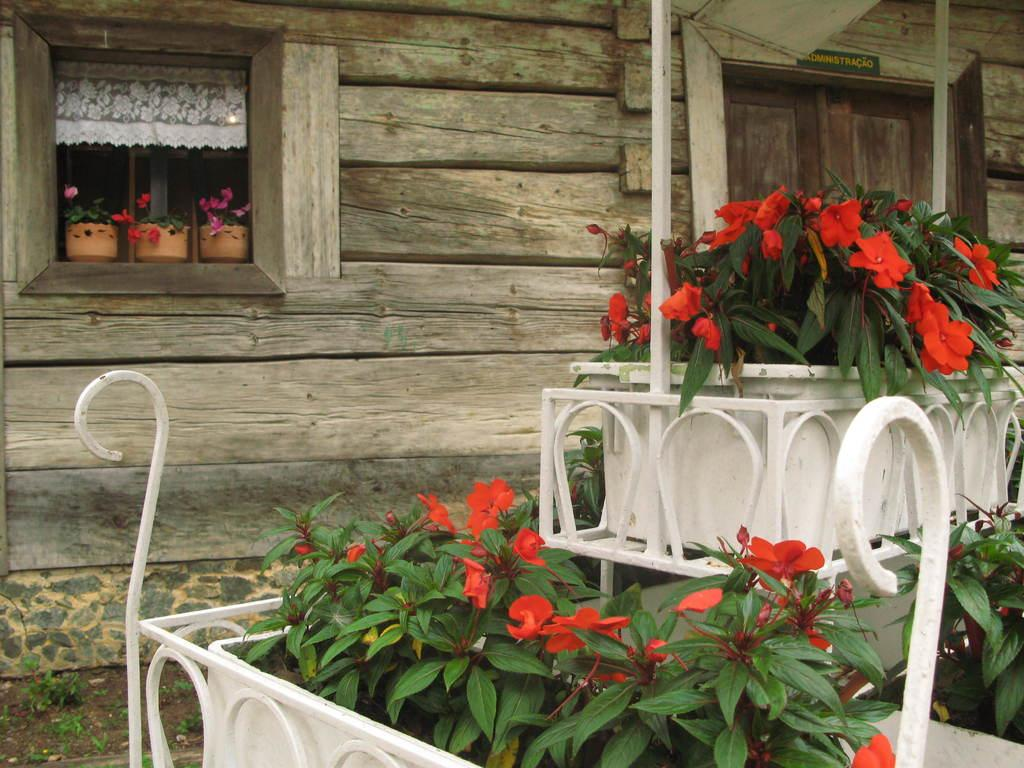What type of plants can be seen in the front of the image? There are flower plants in the front of the image. What structure is visible in the background of the image? There is a house in the background of the image. Where is the door located in the image? The door is on the right side of the image. How many additional plants are present on the left side of the image? There are three more plants on the left side of the image. What type of rings can be seen on the doll's fingers in the image? There is no doll or rings present in the image. Where is the camp located in the image? There is no camp present in the image. 